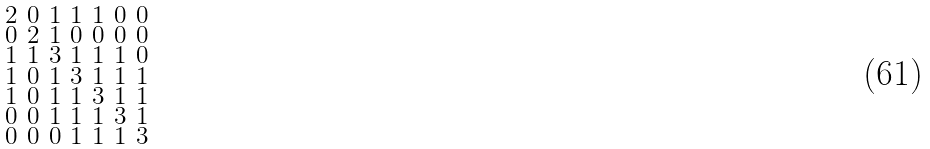<formula> <loc_0><loc_0><loc_500><loc_500>\begin{smallmatrix} 2 & 0 & 1 & 1 & 1 & 0 & 0 \\ 0 & 2 & 1 & 0 & 0 & 0 & 0 \\ 1 & 1 & 3 & 1 & 1 & 1 & 0 \\ 1 & 0 & 1 & 3 & 1 & 1 & 1 \\ 1 & 0 & 1 & 1 & 3 & 1 & 1 \\ 0 & 0 & 1 & 1 & 1 & 3 & 1 \\ 0 & 0 & 0 & 1 & 1 & 1 & 3 \end{smallmatrix}</formula> 